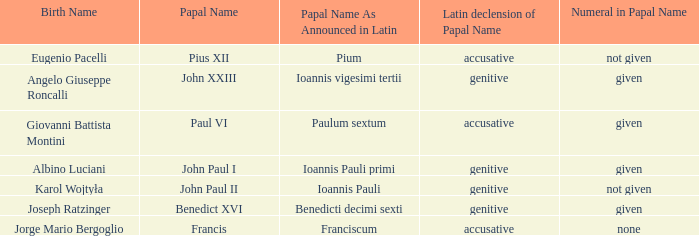For pope paul vi, what is the grammatical change of his pontifical name? Accusative. 